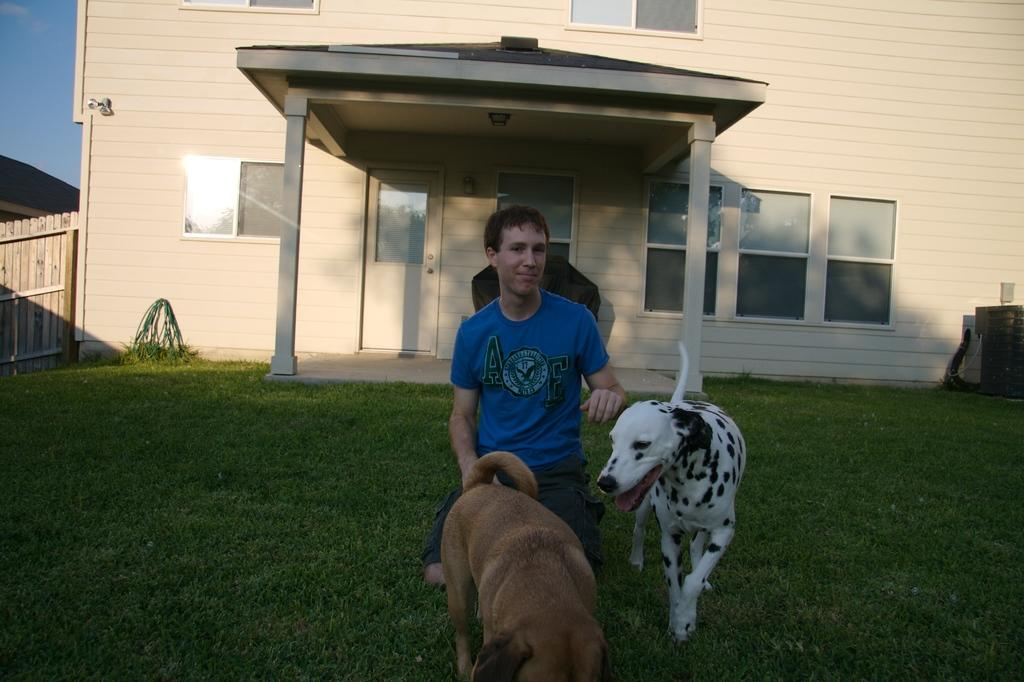Who is present in the image? There is a man in the image. What animals are with the man? The man is accompanied by two dogs. What can be seen in the background of the image? There is a building in the background of the image. Can you describe the building? The building has windows, a door, and pillars. What is on the left side of the image? There is fencing on the left side of the image. What part of the natural environment is visible in the image? The sky is visible in the background of the image. What type of soup is being served in the image? There is no soup present in the image. Can you tell me how many trains are visible in the image? There are no trains visible in the image. 